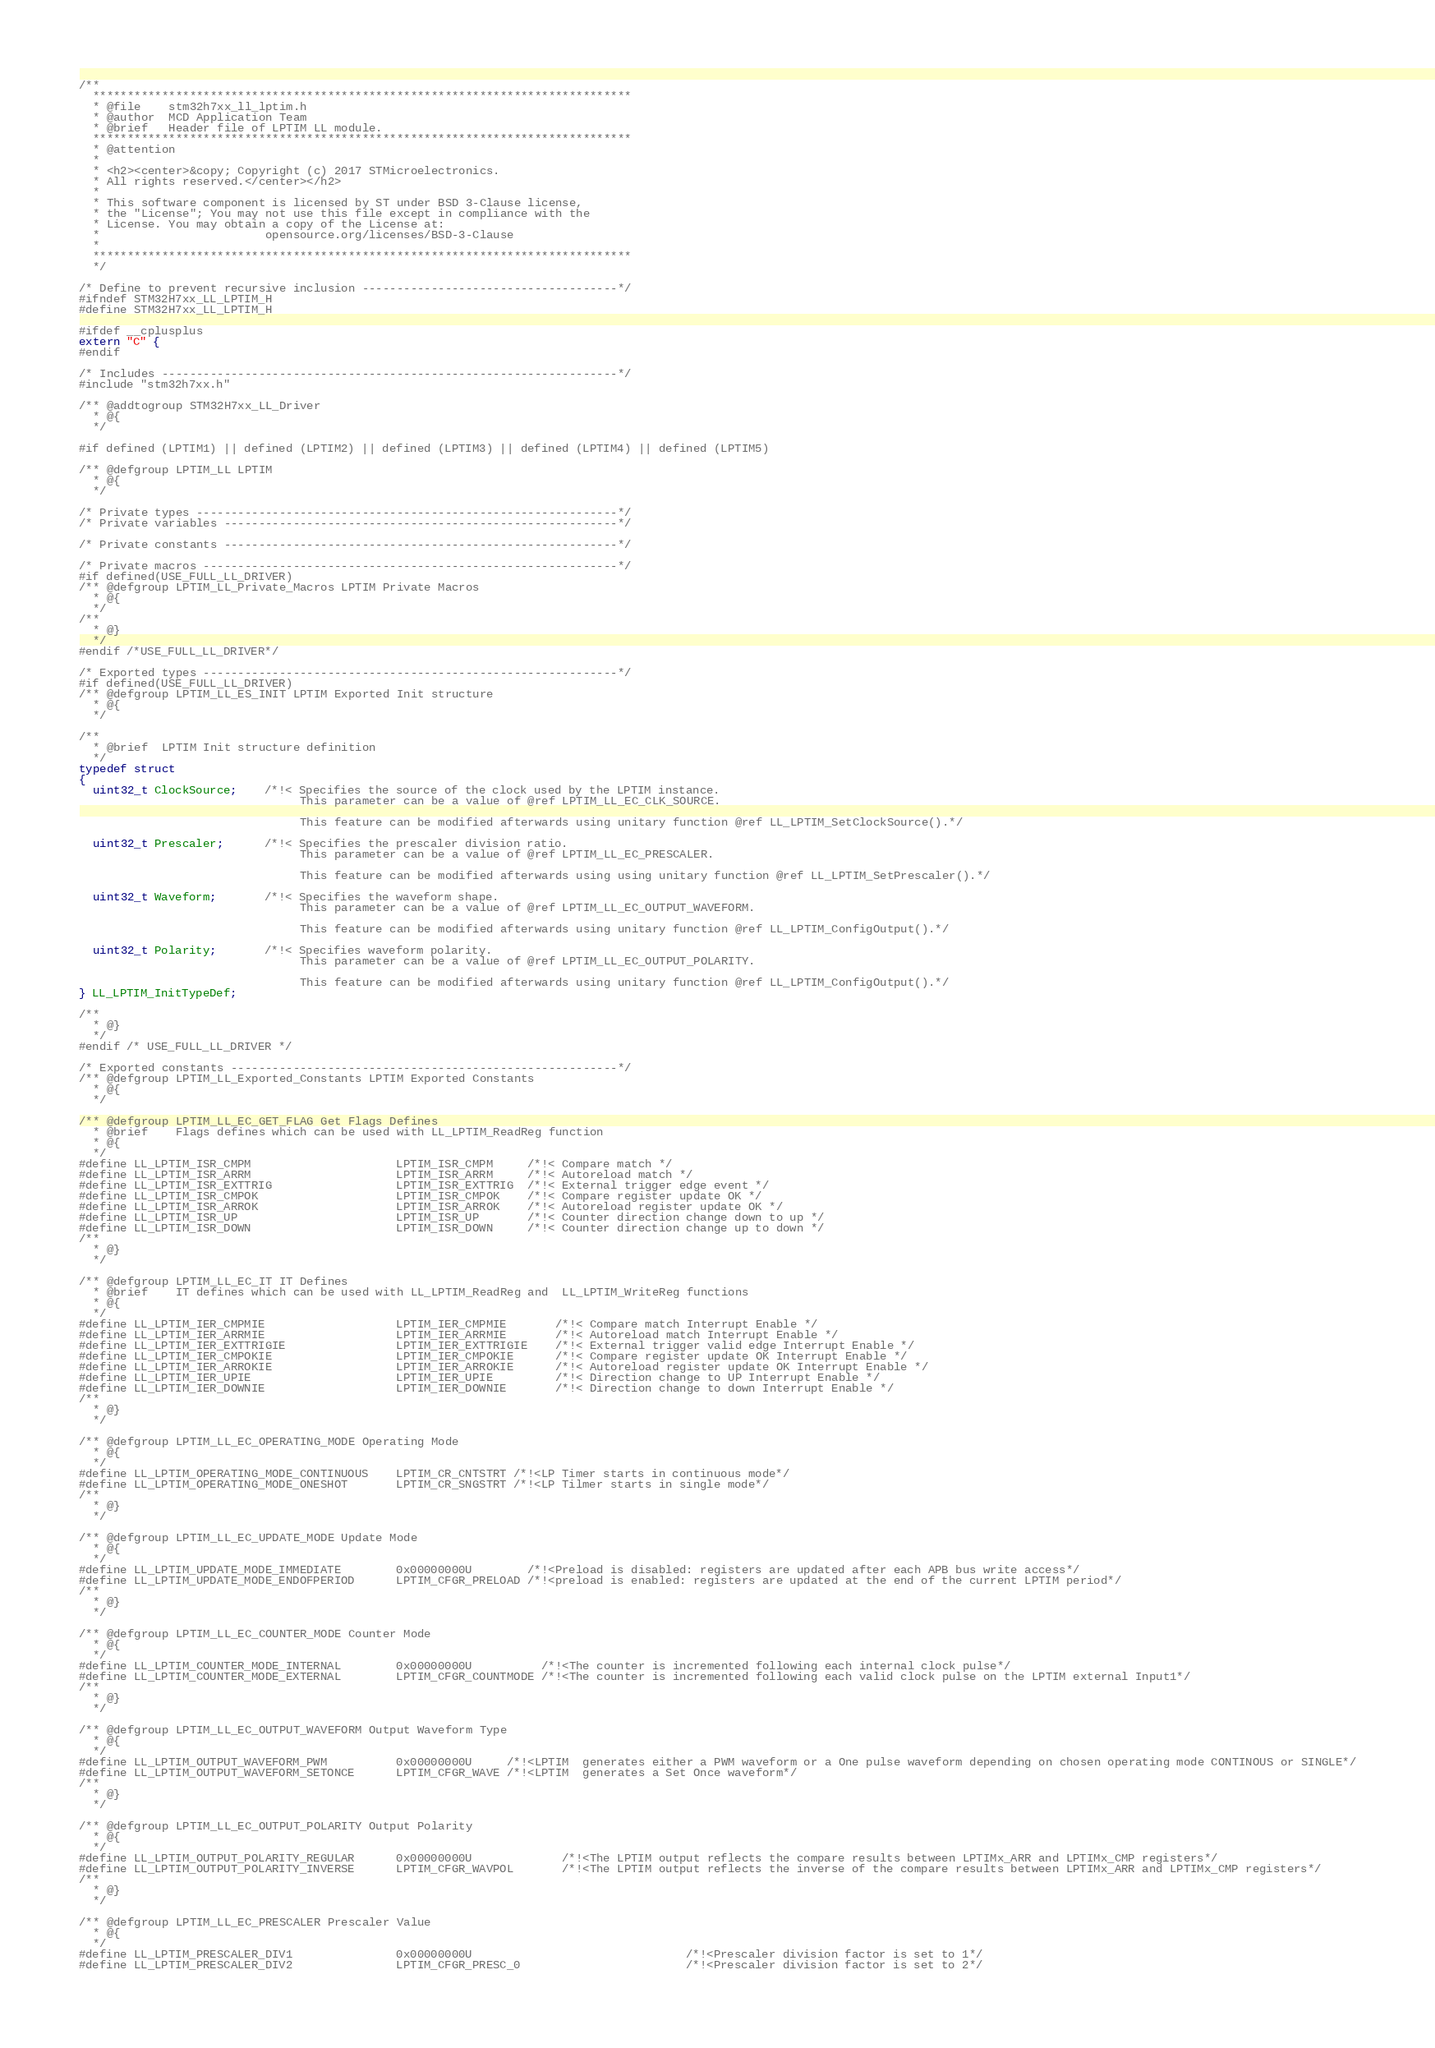Convert code to text. <code><loc_0><loc_0><loc_500><loc_500><_C_>/**
  ******************************************************************************
  * @file    stm32h7xx_ll_lptim.h
  * @author  MCD Application Team
  * @brief   Header file of LPTIM LL module.
  ******************************************************************************
  * @attention
  *
  * <h2><center>&copy; Copyright (c) 2017 STMicroelectronics.
  * All rights reserved.</center></h2>
  *
  * This software component is licensed by ST under BSD 3-Clause license,
  * the "License"; You may not use this file except in compliance with the
  * License. You may obtain a copy of the License at:
  *                        opensource.org/licenses/BSD-3-Clause
  *
  ******************************************************************************
  */

/* Define to prevent recursive inclusion -------------------------------------*/
#ifndef STM32H7xx_LL_LPTIM_H
#define STM32H7xx_LL_LPTIM_H

#ifdef __cplusplus
extern "C" {
#endif

/* Includes ------------------------------------------------------------------*/
#include "stm32h7xx.h"

/** @addtogroup STM32H7xx_LL_Driver
  * @{
  */

#if defined (LPTIM1) || defined (LPTIM2) || defined (LPTIM3) || defined (LPTIM4) || defined (LPTIM5)

/** @defgroup LPTIM_LL LPTIM
  * @{
  */

/* Private types -------------------------------------------------------------*/
/* Private variables ---------------------------------------------------------*/

/* Private constants ---------------------------------------------------------*/

/* Private macros ------------------------------------------------------------*/
#if defined(USE_FULL_LL_DRIVER)
/** @defgroup LPTIM_LL_Private_Macros LPTIM Private Macros
  * @{
  */
/**
  * @}
  */
#endif /*USE_FULL_LL_DRIVER*/

/* Exported types ------------------------------------------------------------*/
#if defined(USE_FULL_LL_DRIVER)
/** @defgroup LPTIM_LL_ES_INIT LPTIM Exported Init structure
  * @{
  */

/**
  * @brief  LPTIM Init structure definition
  */
typedef struct
{
  uint32_t ClockSource;    /*!< Specifies the source of the clock used by the LPTIM instance.
                                This parameter can be a value of @ref LPTIM_LL_EC_CLK_SOURCE.

                                This feature can be modified afterwards using unitary function @ref LL_LPTIM_SetClockSource().*/

  uint32_t Prescaler;      /*!< Specifies the prescaler division ratio.
                                This parameter can be a value of @ref LPTIM_LL_EC_PRESCALER.

                                This feature can be modified afterwards using using unitary function @ref LL_LPTIM_SetPrescaler().*/

  uint32_t Waveform;       /*!< Specifies the waveform shape.
                                This parameter can be a value of @ref LPTIM_LL_EC_OUTPUT_WAVEFORM.

                                This feature can be modified afterwards using unitary function @ref LL_LPTIM_ConfigOutput().*/

  uint32_t Polarity;       /*!< Specifies waveform polarity.
                                This parameter can be a value of @ref LPTIM_LL_EC_OUTPUT_POLARITY.

                                This feature can be modified afterwards using unitary function @ref LL_LPTIM_ConfigOutput().*/
} LL_LPTIM_InitTypeDef;

/**
  * @}
  */
#endif /* USE_FULL_LL_DRIVER */

/* Exported constants --------------------------------------------------------*/
/** @defgroup LPTIM_LL_Exported_Constants LPTIM Exported Constants
  * @{
  */

/** @defgroup LPTIM_LL_EC_GET_FLAG Get Flags Defines
  * @brief    Flags defines which can be used with LL_LPTIM_ReadReg function
  * @{
  */
#define LL_LPTIM_ISR_CMPM                     LPTIM_ISR_CMPM     /*!< Compare match */
#define LL_LPTIM_ISR_ARRM                     LPTIM_ISR_ARRM     /*!< Autoreload match */
#define LL_LPTIM_ISR_EXTTRIG                  LPTIM_ISR_EXTTRIG  /*!< External trigger edge event */
#define LL_LPTIM_ISR_CMPOK                    LPTIM_ISR_CMPOK    /*!< Compare register update OK */
#define LL_LPTIM_ISR_ARROK                    LPTIM_ISR_ARROK    /*!< Autoreload register update OK */
#define LL_LPTIM_ISR_UP                       LPTIM_ISR_UP       /*!< Counter direction change down to up */
#define LL_LPTIM_ISR_DOWN                     LPTIM_ISR_DOWN     /*!< Counter direction change up to down */
/**
  * @}
  */

/** @defgroup LPTIM_LL_EC_IT IT Defines
  * @brief    IT defines which can be used with LL_LPTIM_ReadReg and  LL_LPTIM_WriteReg functions
  * @{
  */
#define LL_LPTIM_IER_CMPMIE                   LPTIM_IER_CMPMIE       /*!< Compare match Interrupt Enable */
#define LL_LPTIM_IER_ARRMIE                   LPTIM_IER_ARRMIE       /*!< Autoreload match Interrupt Enable */
#define LL_LPTIM_IER_EXTTRIGIE                LPTIM_IER_EXTTRIGIE    /*!< External trigger valid edge Interrupt Enable */
#define LL_LPTIM_IER_CMPOKIE                  LPTIM_IER_CMPOKIE      /*!< Compare register update OK Interrupt Enable */
#define LL_LPTIM_IER_ARROKIE                  LPTIM_IER_ARROKIE      /*!< Autoreload register update OK Interrupt Enable */
#define LL_LPTIM_IER_UPIE                     LPTIM_IER_UPIE         /*!< Direction change to UP Interrupt Enable */
#define LL_LPTIM_IER_DOWNIE                   LPTIM_IER_DOWNIE       /*!< Direction change to down Interrupt Enable */
/**
  * @}
  */

/** @defgroup LPTIM_LL_EC_OPERATING_MODE Operating Mode
  * @{
  */
#define LL_LPTIM_OPERATING_MODE_CONTINUOUS    LPTIM_CR_CNTSTRT /*!<LP Timer starts in continuous mode*/
#define LL_LPTIM_OPERATING_MODE_ONESHOT       LPTIM_CR_SNGSTRT /*!<LP Tilmer starts in single mode*/
/**
  * @}
  */

/** @defgroup LPTIM_LL_EC_UPDATE_MODE Update Mode
  * @{
  */
#define LL_LPTIM_UPDATE_MODE_IMMEDIATE        0x00000000U        /*!<Preload is disabled: registers are updated after each APB bus write access*/
#define LL_LPTIM_UPDATE_MODE_ENDOFPERIOD      LPTIM_CFGR_PRELOAD /*!<preload is enabled: registers are updated at the end of the current LPTIM period*/
/**
  * @}
  */

/** @defgroup LPTIM_LL_EC_COUNTER_MODE Counter Mode
  * @{
  */
#define LL_LPTIM_COUNTER_MODE_INTERNAL        0x00000000U          /*!<The counter is incremented following each internal clock pulse*/
#define LL_LPTIM_COUNTER_MODE_EXTERNAL        LPTIM_CFGR_COUNTMODE /*!<The counter is incremented following each valid clock pulse on the LPTIM external Input1*/
/**
  * @}
  */

/** @defgroup LPTIM_LL_EC_OUTPUT_WAVEFORM Output Waveform Type
  * @{
  */
#define LL_LPTIM_OUTPUT_WAVEFORM_PWM          0x00000000U     /*!<LPTIM  generates either a PWM waveform or a One pulse waveform depending on chosen operating mode CONTINOUS or SINGLE*/
#define LL_LPTIM_OUTPUT_WAVEFORM_SETONCE      LPTIM_CFGR_WAVE /*!<LPTIM  generates a Set Once waveform*/
/**
  * @}
  */

/** @defgroup LPTIM_LL_EC_OUTPUT_POLARITY Output Polarity
  * @{
  */
#define LL_LPTIM_OUTPUT_POLARITY_REGULAR      0x00000000U             /*!<The LPTIM output reflects the compare results between LPTIMx_ARR and LPTIMx_CMP registers*/
#define LL_LPTIM_OUTPUT_POLARITY_INVERSE      LPTIM_CFGR_WAVPOL       /*!<The LPTIM output reflects the inverse of the compare results between LPTIMx_ARR and LPTIMx_CMP registers*/
/**
  * @}
  */

/** @defgroup LPTIM_LL_EC_PRESCALER Prescaler Value
  * @{
  */
#define LL_LPTIM_PRESCALER_DIV1               0x00000000U                               /*!<Prescaler division factor is set to 1*/
#define LL_LPTIM_PRESCALER_DIV2               LPTIM_CFGR_PRESC_0                        /*!<Prescaler division factor is set to 2*/</code> 